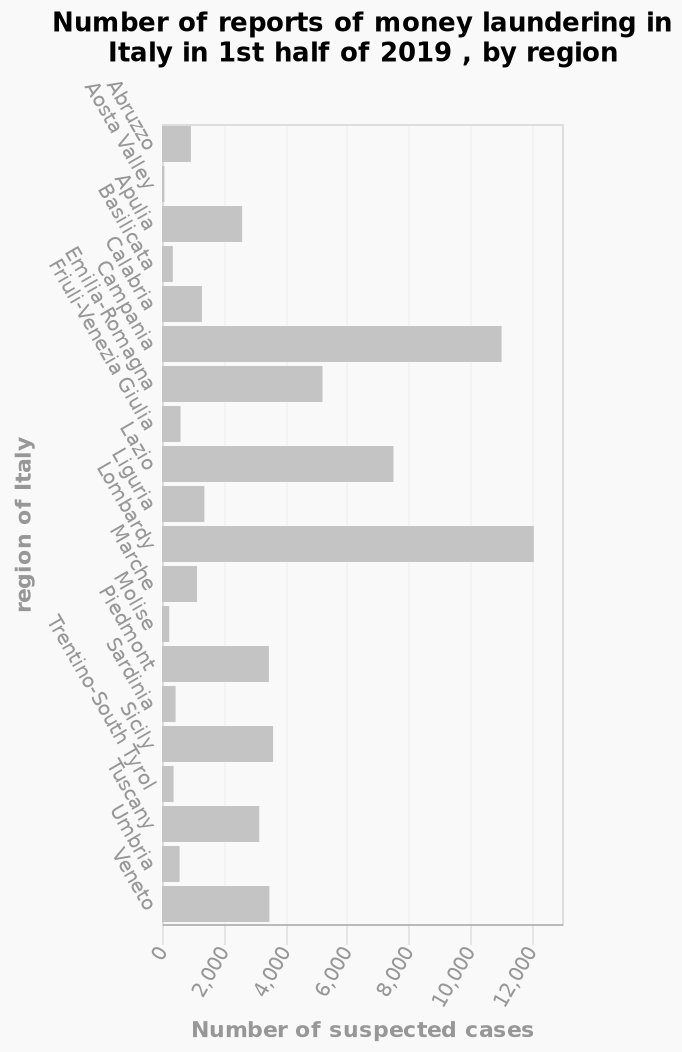<image>
Offer a thorough analysis of the image. Lombardy has the highest amount of money laundering with 12,000. Aosta Valley has the lowest amount of of money laundering. 